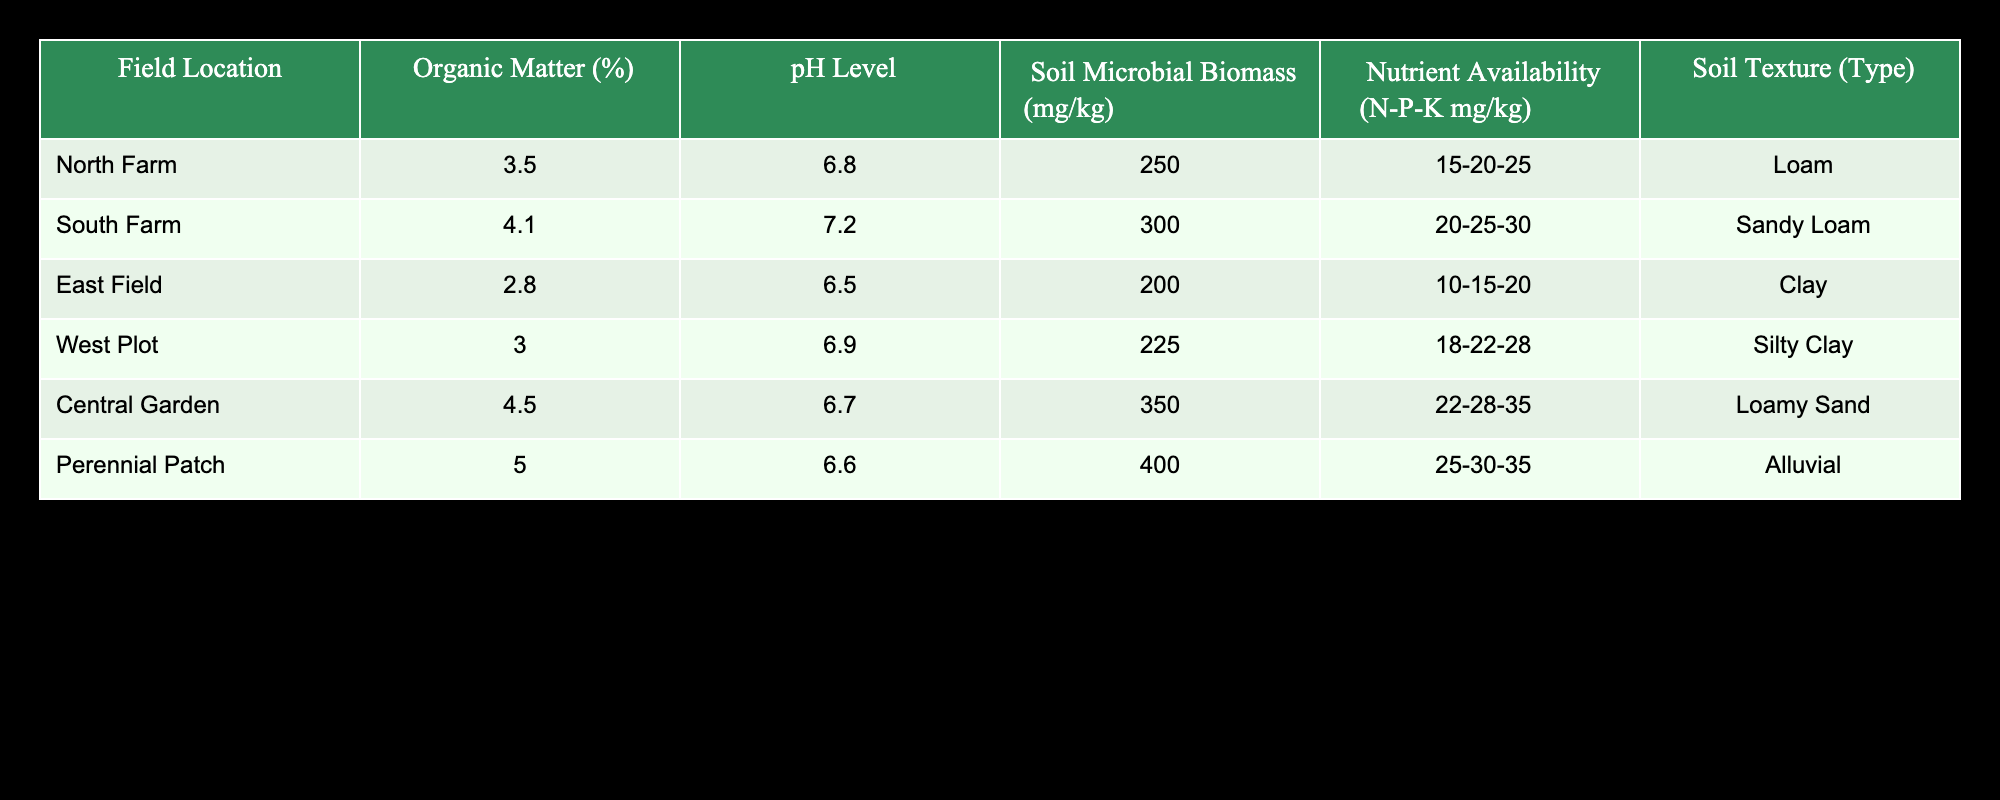What is the pH level at the Central Garden? The pH level for the Central Garden is explicitly listed in the table under the pH Level column. It shows a value of 6.7.
Answer: 6.7 Which field has the highest soil microbial biomass? To identify the field with the highest soil microbial biomass, I compare the values listed in the Soil Microbial Biomass column. The Perennial Patch has the highest value at 400 mg/kg.
Answer: Perennial Patch What is the average Organic Matter percentage across all fields? To find the average, I first sum up the Organic Matter percentages: 3.5 + 4.1 + 2.8 + 3.0 + 4.5 + 5.0 = 23.0. There are 6 fields, so I divide the sum by 6: 23.0 / 6 = 3.83.
Answer: 3.83 Is the Nutrient Availability at the East Field higher than at the South Farm? By examining the Nutrient Availability (N-P-K mg/kg) values for both fields, the East Field has a value of 10-15-20, while the South Farm has 20-25-30. The South Farm’s values are higher, making the statement false.
Answer: No Which field has the lowest soil texture type score based on the listed types? The soil texture type can be considered qualitatively, and among the listed types, Clay (found at the East Field) generally has lower fertility characteristics compared to Loam or Sandy Loam. Thus, the East Field has the lowest texture score.
Answer: East Field Calculate the difference in soil microbial biomass between the Central Garden and the North Farm. The soil microbial biomass of Central Garden is 350 mg/kg and that of North Farm is 250 mg/kg. The difference is 350 - 250 = 100 mg/kg.
Answer: 100 mg/kg Is the Organic Matter percentage higher at the South Farm compared to the West Plot? The Organic Matter percentage for the South Farm is 4.1%, while for the West Plot, it is 3.0%. Since 4.1% is greater than 3.0%, the statement is true.
Answer: Yes What is the most nutrient-rich field based on the Nutrient Availability values? Evaluating the Nutrient Availability values across all fields, the field with the highest values is the Perennial Patch with 25-30-35, indicating it has higher nutrient richness compared to the others.
Answer: Perennial Patch 